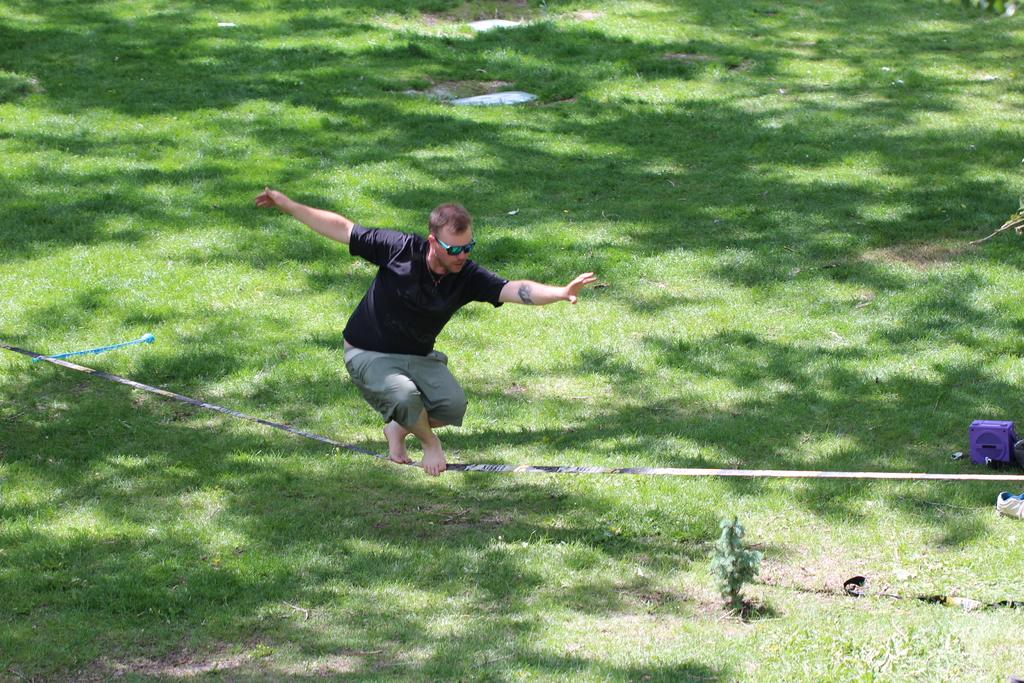What is the man doing in the image? The man is standing on a rope in the image. What type of vegetation is present in the image? There is a plant and grass on the ground in the image. What can be seen on the man's feet? There is footwear visible in the image. What object can be seen in the image that is not related to the man or vegetation? There is a box in the image. What type of animal is visible in the image? There is no animal present in the image. What type of badge is the man wearing in the image? There is no badge visible in the image. 